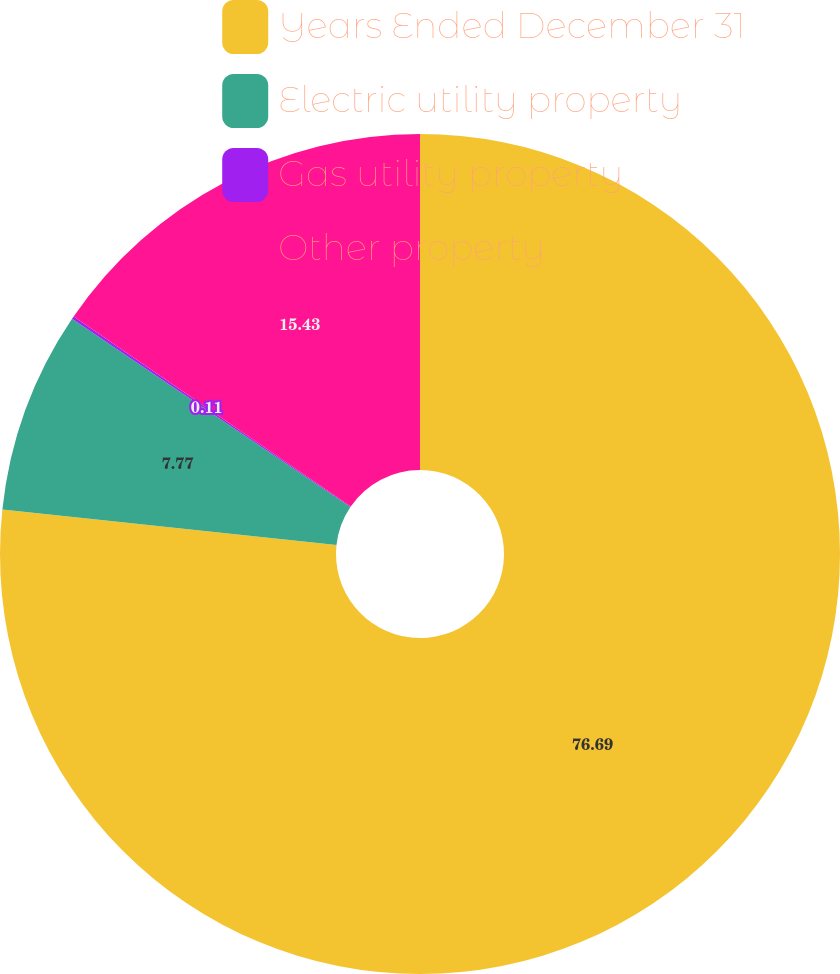Convert chart. <chart><loc_0><loc_0><loc_500><loc_500><pie_chart><fcel>Years Ended December 31<fcel>Electric utility property<fcel>Gas utility property<fcel>Other property<nl><fcel>76.69%<fcel>7.77%<fcel>0.11%<fcel>15.43%<nl></chart> 